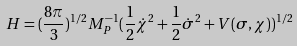<formula> <loc_0><loc_0><loc_500><loc_500>H = ( \frac { 8 \pi } { 3 } ) ^ { 1 / 2 } M _ { P } ^ { - 1 } ( \frac { 1 } { 2 } \dot { \chi } ^ { 2 } + \frac { 1 } { 2 } \dot { \sigma } ^ { 2 } + V ( \sigma , \chi ) ) ^ { 1 / 2 }</formula> 